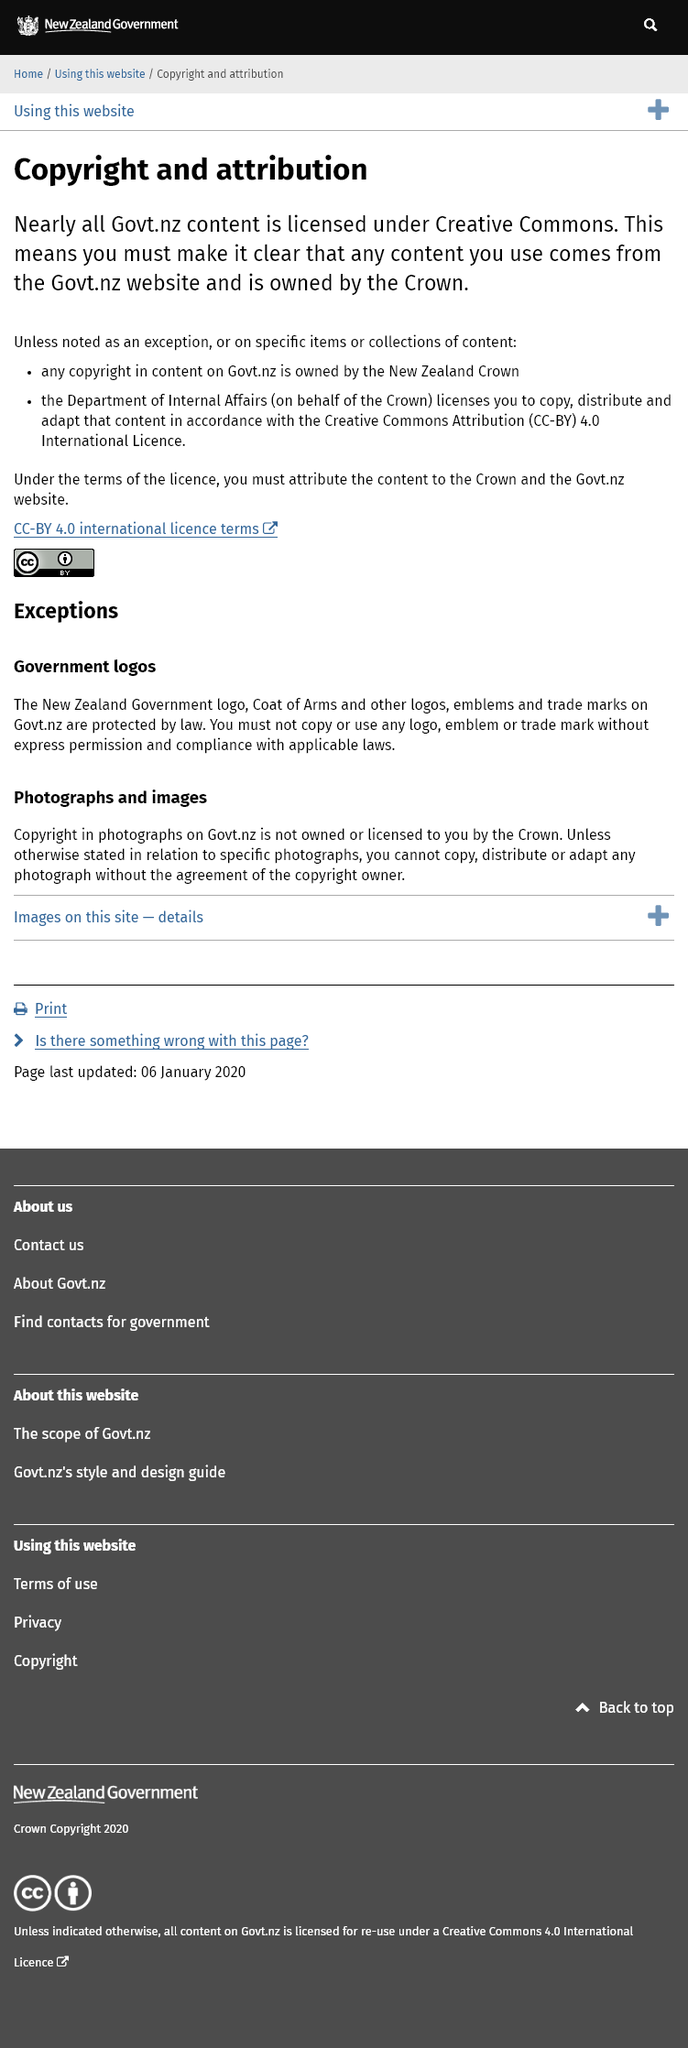List a handful of essential elements in this visual. Most content on Govt.nz is licensed under Creative Commons. The New Zealand Crown owns the copyright of the content that comes from the Govt.nz website. You must clearly state that any content you use is owned by the Crown and that you are allowed to copy it under the Creative Commons Attribution (CC-BY) 4.0 International Licence. 